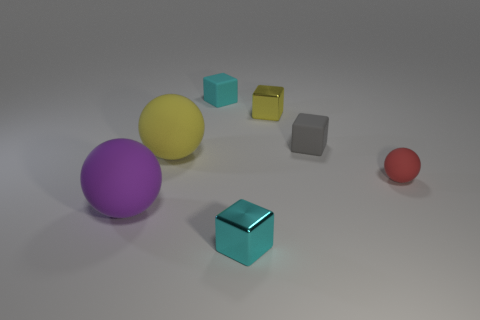There is a tiny rubber block that is to the right of the tiny cyan rubber thing; how many objects are left of it?
Give a very brief answer. 5. Is there anything else that is the same shape as the big yellow thing?
Your answer should be very brief. Yes. There is a matte cube that is behind the gray block; is its color the same as the tiny metal thing behind the yellow rubber sphere?
Ensure brevity in your answer.  No. Is the number of purple matte objects less than the number of small green matte things?
Give a very brief answer. No. What shape is the cyan thing that is in front of the cyan object behind the small gray rubber thing?
Your response must be concise. Cube. Are there any other things that are the same size as the yellow shiny thing?
Your answer should be compact. Yes. What shape is the small metal object that is in front of the big yellow rubber thing that is left of the small metal cube that is in front of the big yellow ball?
Make the answer very short. Cube. What number of things are shiny blocks that are in front of the big yellow thing or cubes that are to the right of the small yellow metal cube?
Provide a short and direct response. 2. There is a gray cube; is its size the same as the cyan cube in front of the small red matte sphere?
Keep it short and to the point. Yes. Is the material of the cyan cube that is in front of the big yellow object the same as the cube behind the tiny yellow thing?
Provide a succinct answer. No. 